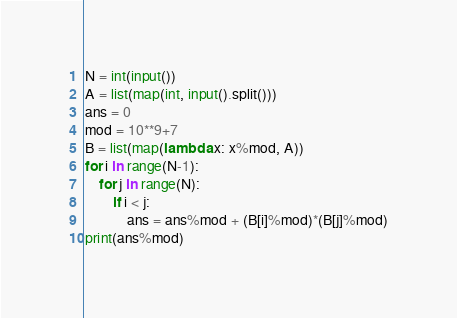<code> <loc_0><loc_0><loc_500><loc_500><_Python_>N = int(input())
A = list(map(int, input().split()))
ans = 0
mod = 10**9+7
B = list(map(lambda x: x%mod, A))
for i in range(N-1):
    for j in range(N):
        if i < j:
            ans = ans%mod + (B[i]%mod)*(B[j]%mod)
print(ans%mod)</code> 